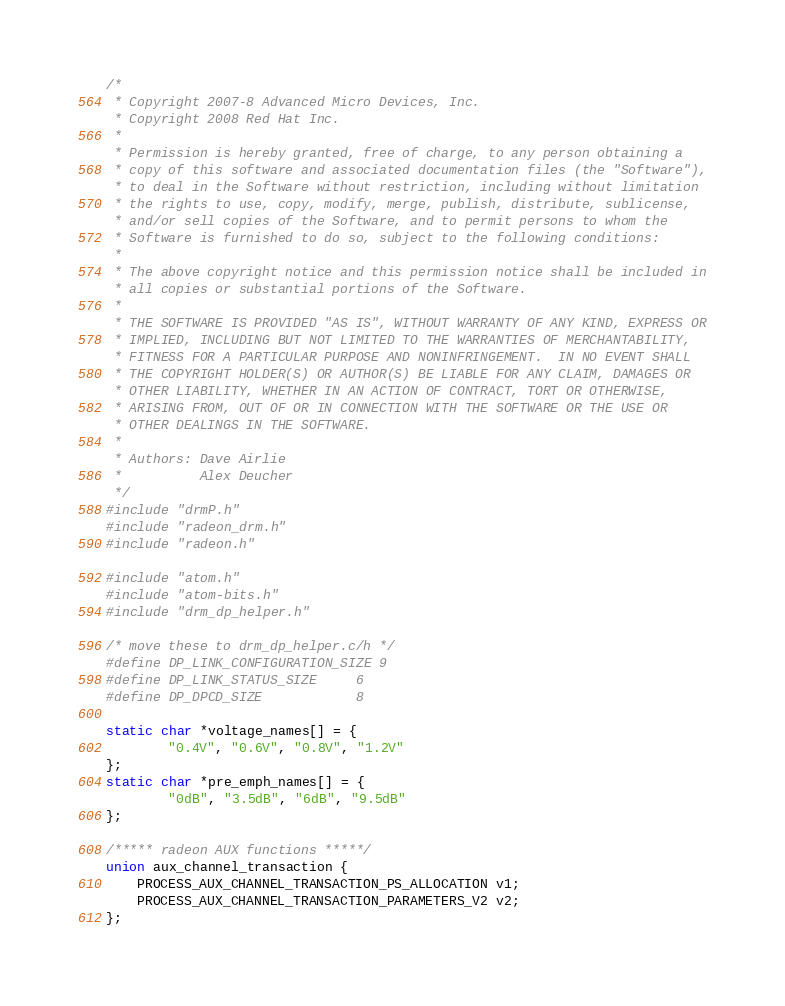Convert code to text. <code><loc_0><loc_0><loc_500><loc_500><_C_>/*
 * Copyright 2007-8 Advanced Micro Devices, Inc.
 * Copyright 2008 Red Hat Inc.
 *
 * Permission is hereby granted, free of charge, to any person obtaining a
 * copy of this software and associated documentation files (the "Software"),
 * to deal in the Software without restriction, including without limitation
 * the rights to use, copy, modify, merge, publish, distribute, sublicense,
 * and/or sell copies of the Software, and to permit persons to whom the
 * Software is furnished to do so, subject to the following conditions:
 *
 * The above copyright notice and this permission notice shall be included in
 * all copies or substantial portions of the Software.
 *
 * THE SOFTWARE IS PROVIDED "AS IS", WITHOUT WARRANTY OF ANY KIND, EXPRESS OR
 * IMPLIED, INCLUDING BUT NOT LIMITED TO THE WARRANTIES OF MERCHANTABILITY,
 * FITNESS FOR A PARTICULAR PURPOSE AND NONINFRINGEMENT.  IN NO EVENT SHALL
 * THE COPYRIGHT HOLDER(S) OR AUTHOR(S) BE LIABLE FOR ANY CLAIM, DAMAGES OR
 * OTHER LIABILITY, WHETHER IN AN ACTION OF CONTRACT, TORT OR OTHERWISE,
 * ARISING FROM, OUT OF OR IN CONNECTION WITH THE SOFTWARE OR THE USE OR
 * OTHER DEALINGS IN THE SOFTWARE.
 *
 * Authors: Dave Airlie
 *          Alex Deucher
 */
#include "drmP.h"
#include "radeon_drm.h"
#include "radeon.h"

#include "atom.h"
#include "atom-bits.h"
#include "drm_dp_helper.h"

/* move these to drm_dp_helper.c/h */
#define DP_LINK_CONFIGURATION_SIZE 9
#define DP_LINK_STATUS_SIZE	   6
#define DP_DPCD_SIZE	           8

static char *voltage_names[] = {
        "0.4V", "0.6V", "0.8V", "1.2V"
};
static char *pre_emph_names[] = {
        "0dB", "3.5dB", "6dB", "9.5dB"
};

/***** radeon AUX functions *****/
union aux_channel_transaction {
	PROCESS_AUX_CHANNEL_TRANSACTION_PS_ALLOCATION v1;
	PROCESS_AUX_CHANNEL_TRANSACTION_PARAMETERS_V2 v2;
};
</code> 